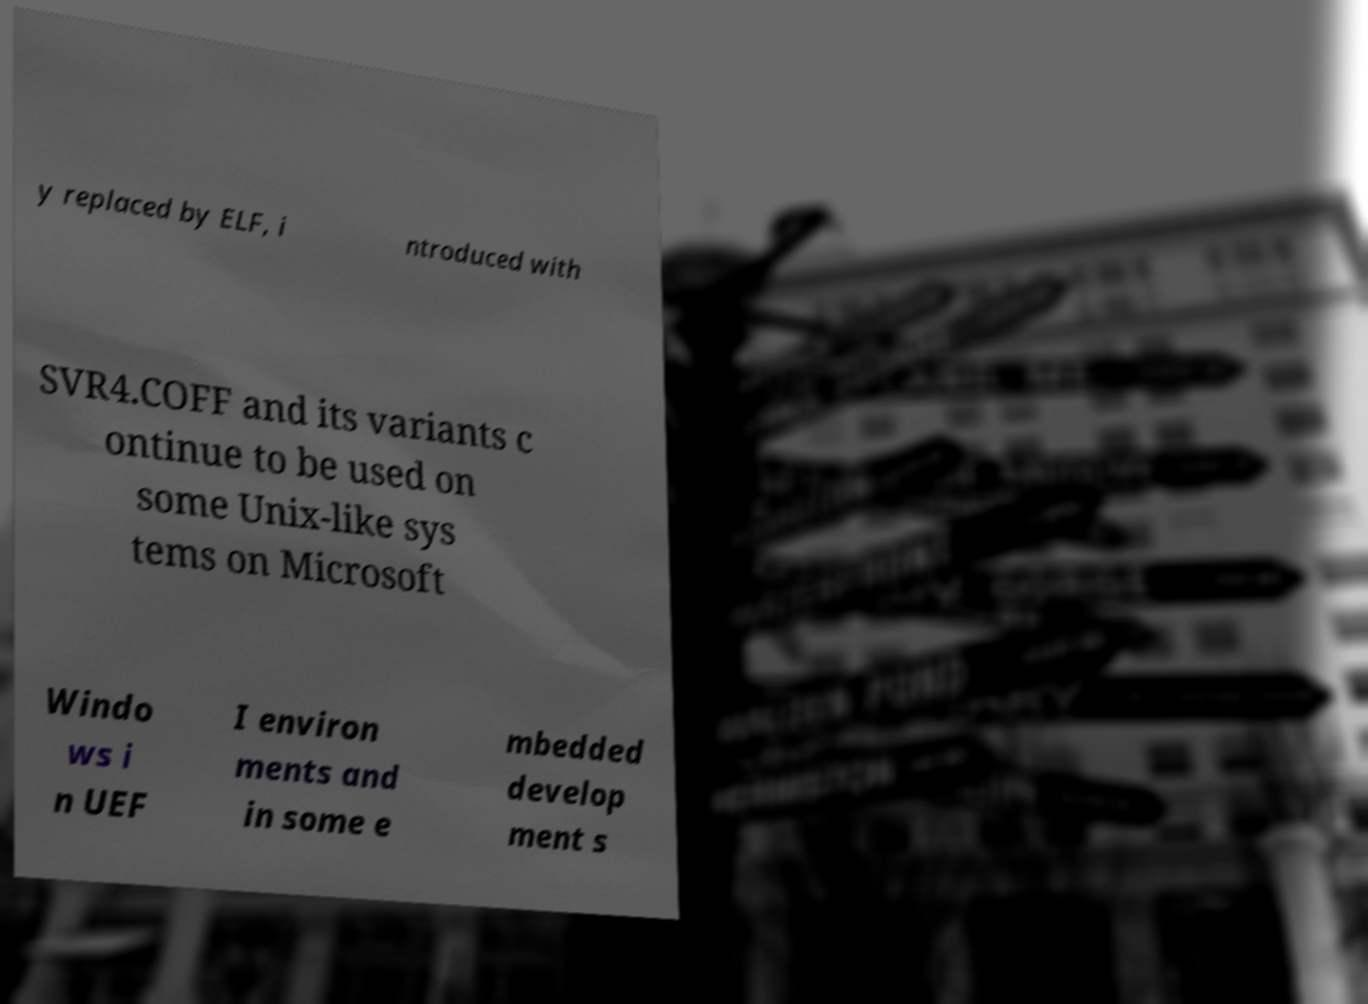What messages or text are displayed in this image? I need them in a readable, typed format. y replaced by ELF, i ntroduced with SVR4.COFF and its variants c ontinue to be used on some Unix-like sys tems on Microsoft Windo ws i n UEF I environ ments and in some e mbedded develop ment s 